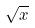<formula> <loc_0><loc_0><loc_500><loc_500>\sqrt { x }</formula> 